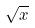<formula> <loc_0><loc_0><loc_500><loc_500>\sqrt { x }</formula> 